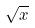<formula> <loc_0><loc_0><loc_500><loc_500>\sqrt { x }</formula> 